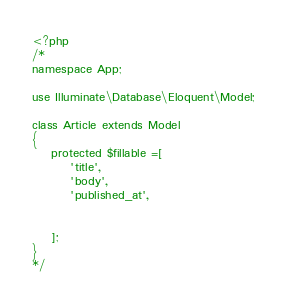<code> <loc_0><loc_0><loc_500><loc_500><_PHP_><?php
/*
namespace App;

use Illuminate\Database\Eloquent\Model;

class Article extends Model
{
    protected $fillable =[
		'title',
		'body',
		'published_at',
	 
	
	];
}
*/
</code> 